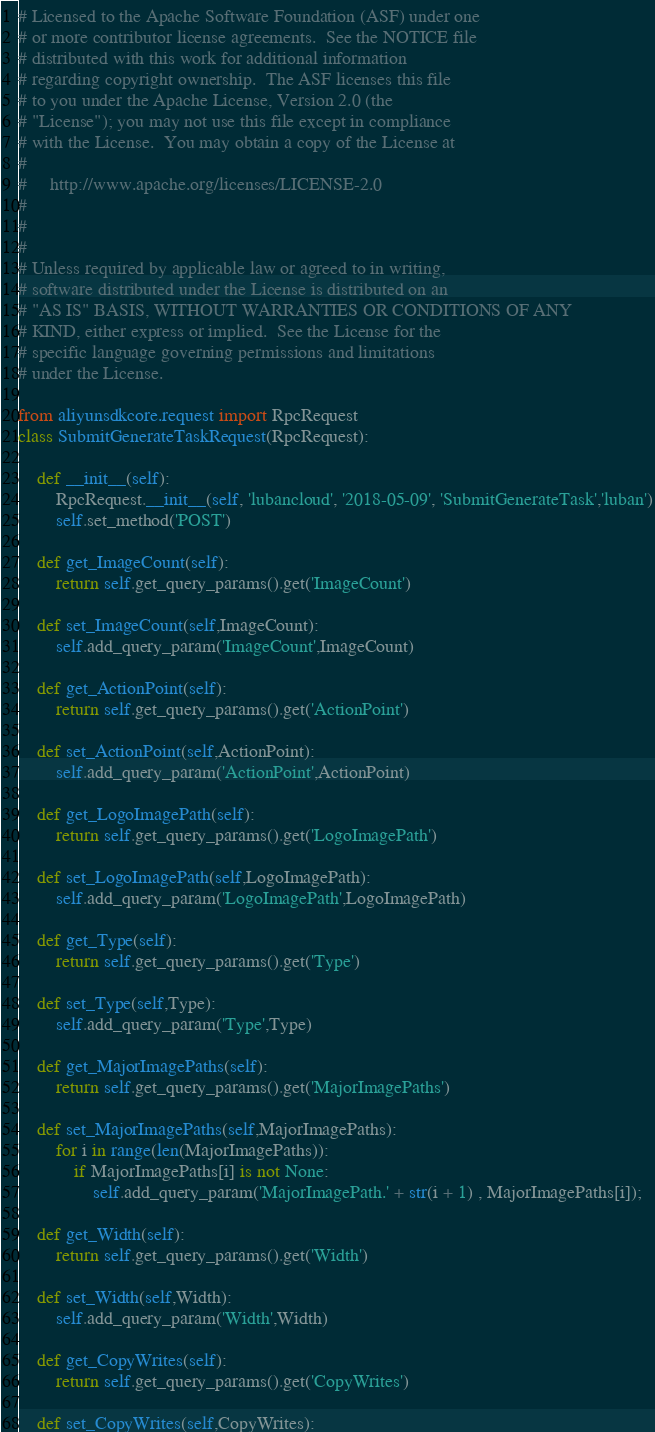Convert code to text. <code><loc_0><loc_0><loc_500><loc_500><_Python_># Licensed to the Apache Software Foundation (ASF) under one
# or more contributor license agreements.  See the NOTICE file
# distributed with this work for additional information
# regarding copyright ownership.  The ASF licenses this file
# to you under the Apache License, Version 2.0 (the
# "License"); you may not use this file except in compliance
# with the License.  You may obtain a copy of the License at
#
#     http://www.apache.org/licenses/LICENSE-2.0
#
#
#
# Unless required by applicable law or agreed to in writing,
# software distributed under the License is distributed on an
# "AS IS" BASIS, WITHOUT WARRANTIES OR CONDITIONS OF ANY
# KIND, either express or implied.  See the License for the
# specific language governing permissions and limitations
# under the License.

from aliyunsdkcore.request import RpcRequest
class SubmitGenerateTaskRequest(RpcRequest):

	def __init__(self):
		RpcRequest.__init__(self, 'lubancloud', '2018-05-09', 'SubmitGenerateTask','luban')
		self.set_method('POST')

	def get_ImageCount(self):
		return self.get_query_params().get('ImageCount')

	def set_ImageCount(self,ImageCount):
		self.add_query_param('ImageCount',ImageCount)

	def get_ActionPoint(self):
		return self.get_query_params().get('ActionPoint')

	def set_ActionPoint(self,ActionPoint):
		self.add_query_param('ActionPoint',ActionPoint)

	def get_LogoImagePath(self):
		return self.get_query_params().get('LogoImagePath')

	def set_LogoImagePath(self,LogoImagePath):
		self.add_query_param('LogoImagePath',LogoImagePath)

	def get_Type(self):
		return self.get_query_params().get('Type')

	def set_Type(self,Type):
		self.add_query_param('Type',Type)

	def get_MajorImagePaths(self):
		return self.get_query_params().get('MajorImagePaths')

	def set_MajorImagePaths(self,MajorImagePaths):
		for i in range(len(MajorImagePaths)):	
			if MajorImagePaths[i] is not None:
				self.add_query_param('MajorImagePath.' + str(i + 1) , MajorImagePaths[i]);

	def get_Width(self):
		return self.get_query_params().get('Width')

	def set_Width(self,Width):
		self.add_query_param('Width',Width)

	def get_CopyWrites(self):
		return self.get_query_params().get('CopyWrites')

	def set_CopyWrites(self,CopyWrites):</code> 